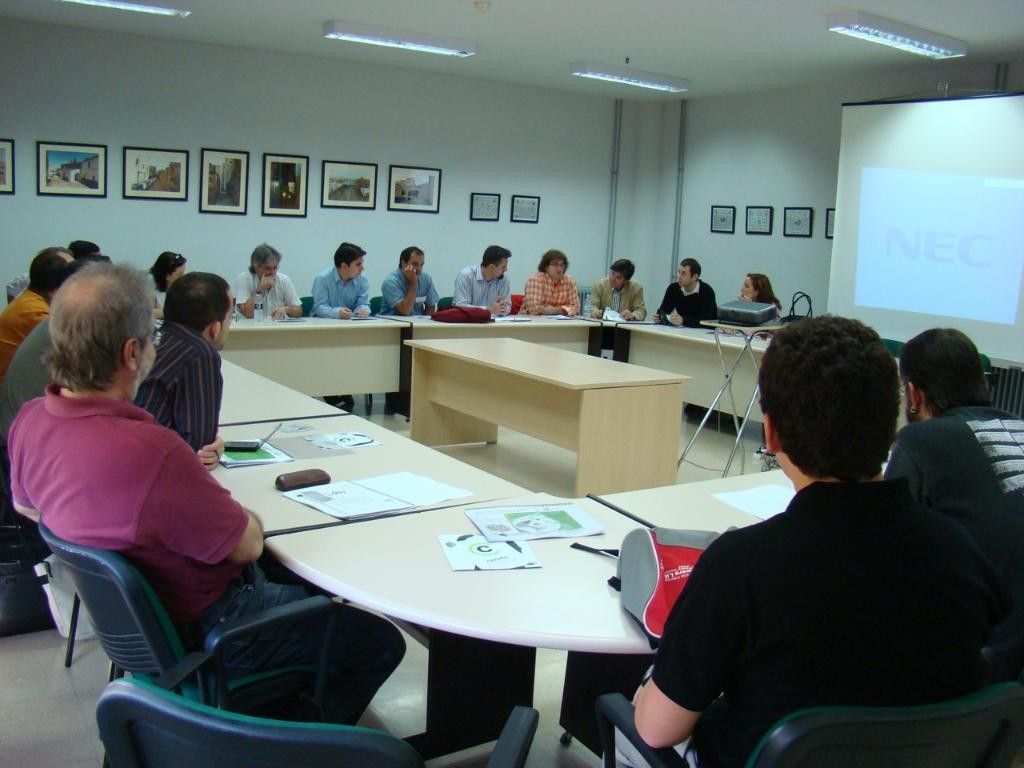What are the people in the image doing? The people in the image are sitting on chairs near tables. What can be seen in the background of the image? There is a wall in the background of the image. What features are present on the wall? The wall has photo frames and lights. Can you describe the texture of the snake in the image? There is no snake present in the image, so we cannot describe its texture. 